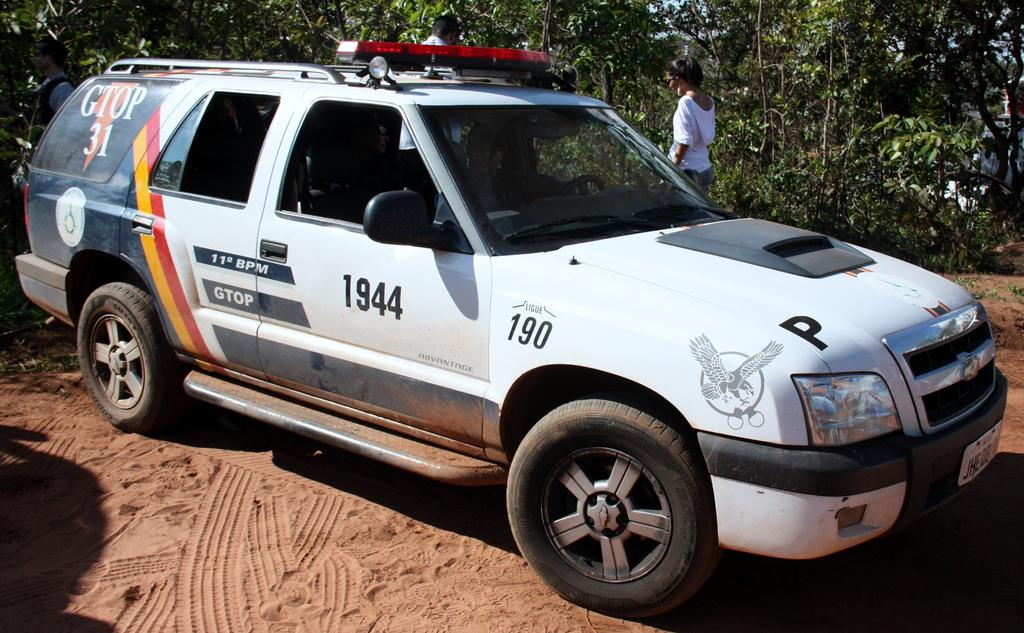What is the main subject in the center of the image? There is a vehicle in the center of the image. Can you describe the position of the vehicle in the image? The vehicle is on the ground. What can be seen in the background of the image? There are trees and people visible in the background of the image. What type of horn is the doll playing in the image? There is no doll or horn present in the image. Can you describe the beetle crawling on the vehicle in the image? There is no beetle visible on the vehicle in the image. 